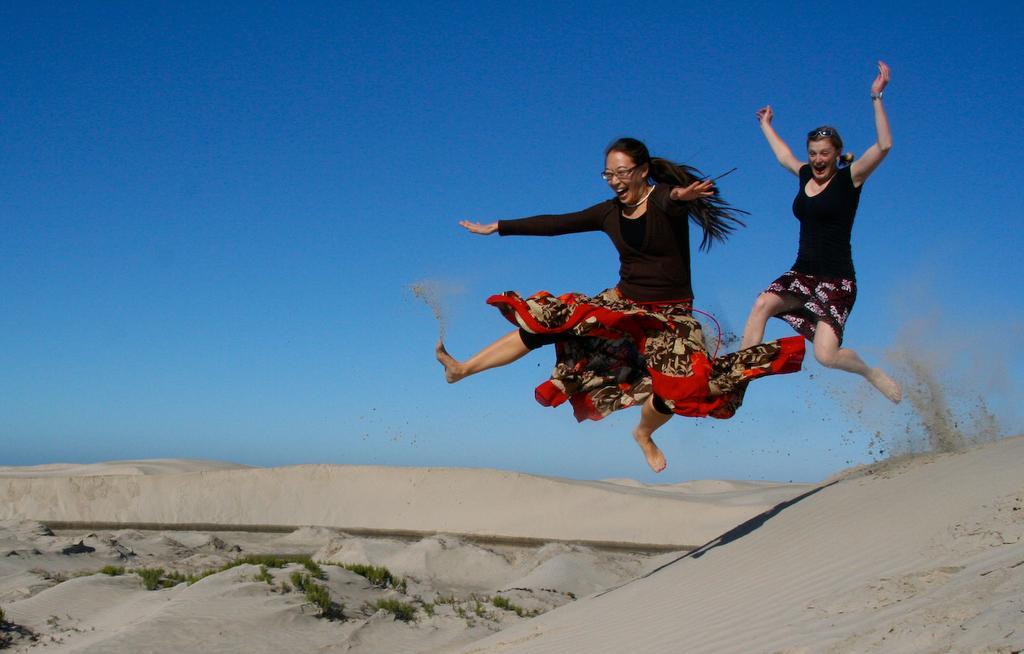Can you describe this image briefly? In this picture we can see two women are jumping, at the bottom there is sand, we can see plants in the middle, we can see the sky at the top of the picture. 